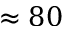<formula> <loc_0><loc_0><loc_500><loc_500>\approx 8 0</formula> 